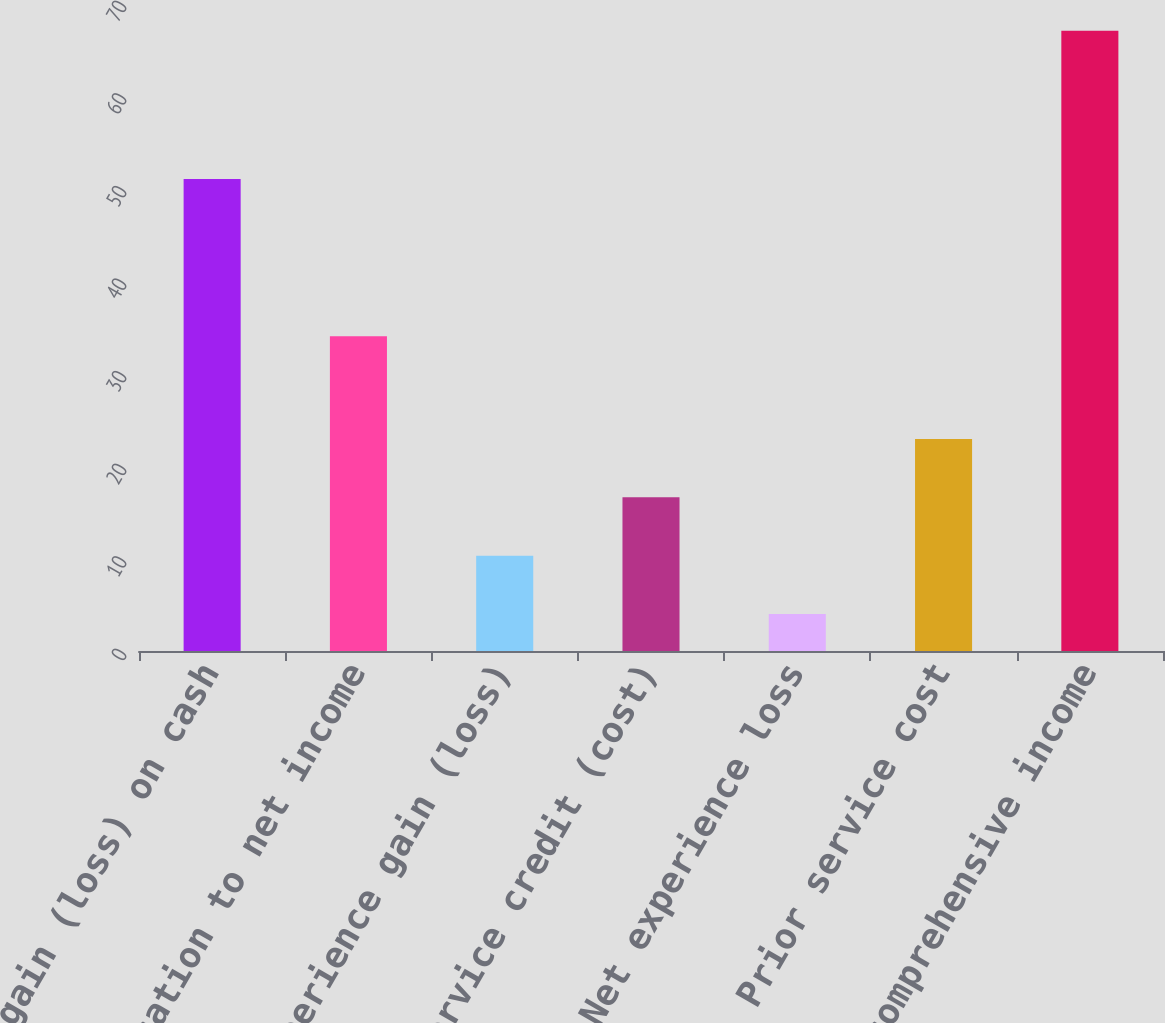<chart> <loc_0><loc_0><loc_500><loc_500><bar_chart><fcel>Unrealized gain (loss) on cash<fcel>Reclassification to net income<fcel>Net experience gain (loss)<fcel>Prior service credit (cost)<fcel>Net experience loss<fcel>Prior service cost<fcel>Other comprehensive income<nl><fcel>51<fcel>34<fcel>10.3<fcel>16.6<fcel>4<fcel>22.9<fcel>67<nl></chart> 